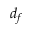Convert formula to latex. <formula><loc_0><loc_0><loc_500><loc_500>d _ { f }</formula> 